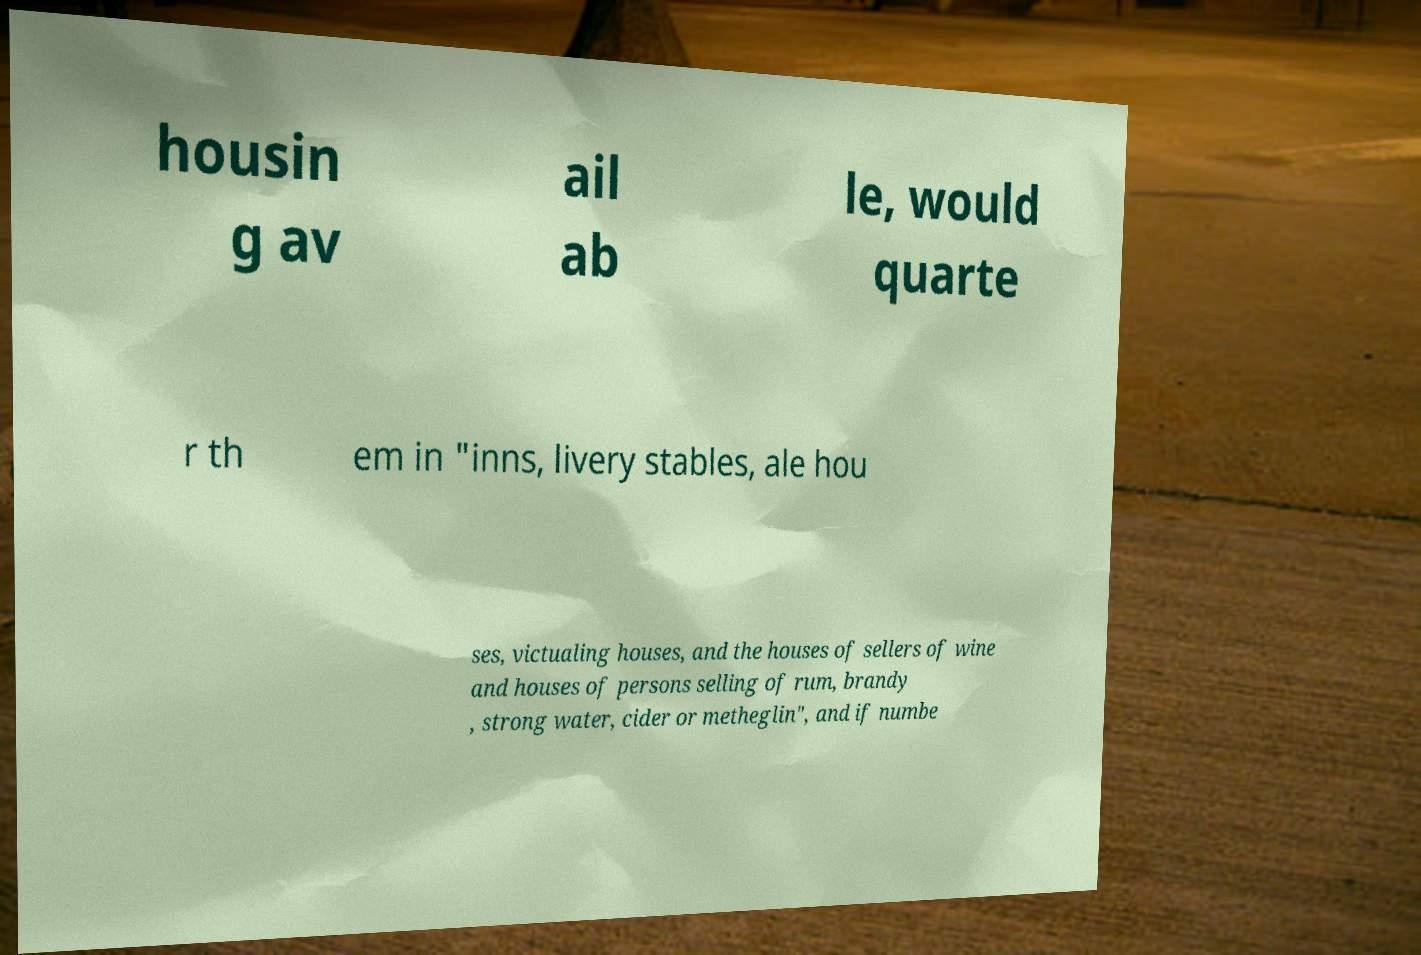What messages or text are displayed in this image? I need them in a readable, typed format. housin g av ail ab le, would quarte r th em in "inns, livery stables, ale hou ses, victualing houses, and the houses of sellers of wine and houses of persons selling of rum, brandy , strong water, cider or metheglin", and if numbe 